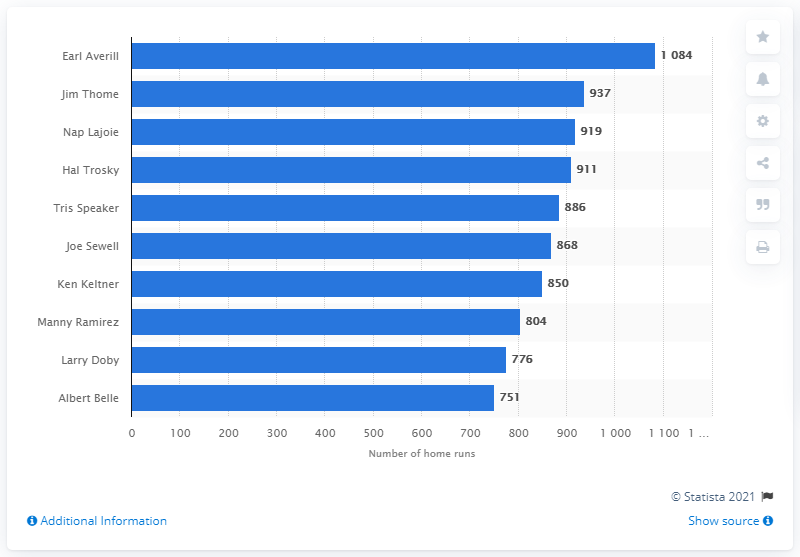Give some essential details in this illustration. Earl Averill holds the record for the most RBI in the history of the Cleveland Indians franchise. 